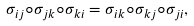Convert formula to latex. <formula><loc_0><loc_0><loc_500><loc_500>\sigma _ { i j } \circ \sigma _ { j k } \circ \sigma _ { k i } = \sigma _ { i k } \circ \sigma _ { k j } \circ \sigma _ { j i } ,</formula> 